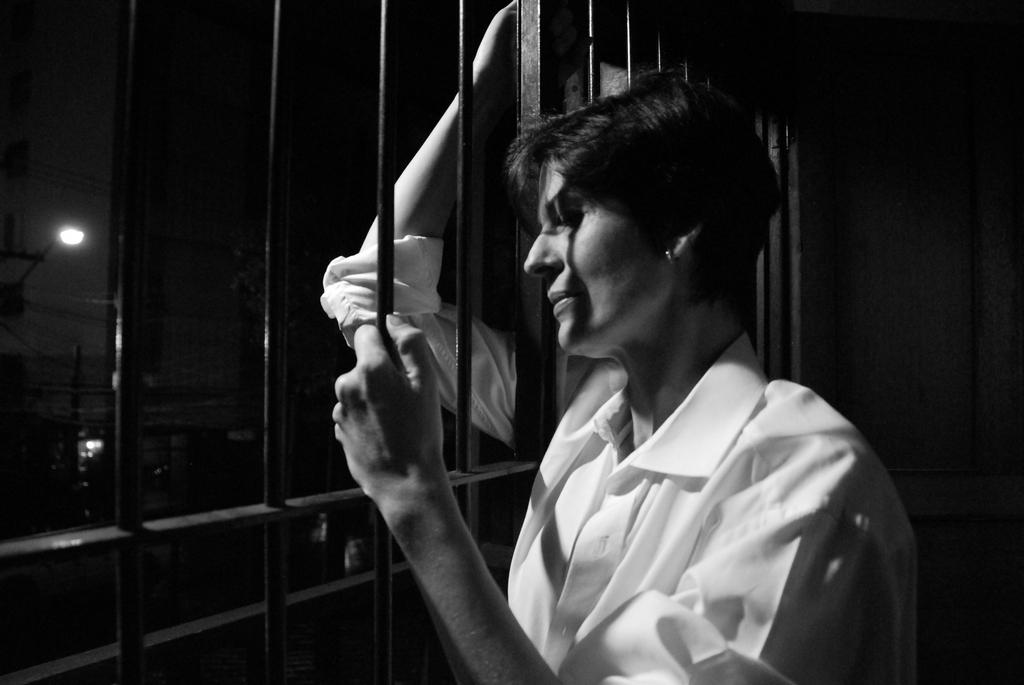What is the main subject of the image? There is a person standing in the image. What objects can be seen in the background? There is an iron grill and a street light in the image. What type of plastic is covering the street light in the image? There is no plastic covering the street light in the image; it is a metal structure with a light source on top. 